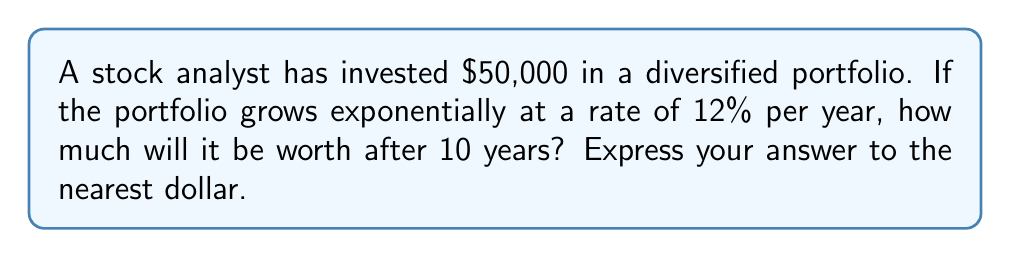Could you help me with this problem? To solve this problem, we'll use the exponential growth formula:

$$A = P(1 + r)^t$$

Where:
$A$ = Final amount
$P$ = Principal (initial investment)
$r$ = Annual growth rate (as a decimal)
$t$ = Time in years

Given:
$P = $50,000$
$r = 12\% = 0.12$
$t = 10$ years

Let's substitute these values into the formula:

$$A = 50000(1 + 0.12)^{10}$$

Now, let's calculate step by step:

1) First, calculate $(1 + 0.12)$:
   $1 + 0.12 = 1.12$

2) Now, raise 1.12 to the power of 10:
   $1.12^{10} \approx 3.1058$

3) Multiply this by the initial investment:
   $50000 \times 3.1058 = 155,290$

4) Round to the nearest dollar:
   $155,290$

Therefore, after 10 years, the portfolio will be worth $155,290.
Answer: $155,290 